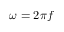Convert formula to latex. <formula><loc_0><loc_0><loc_500><loc_500>\omega = 2 \pi f</formula> 